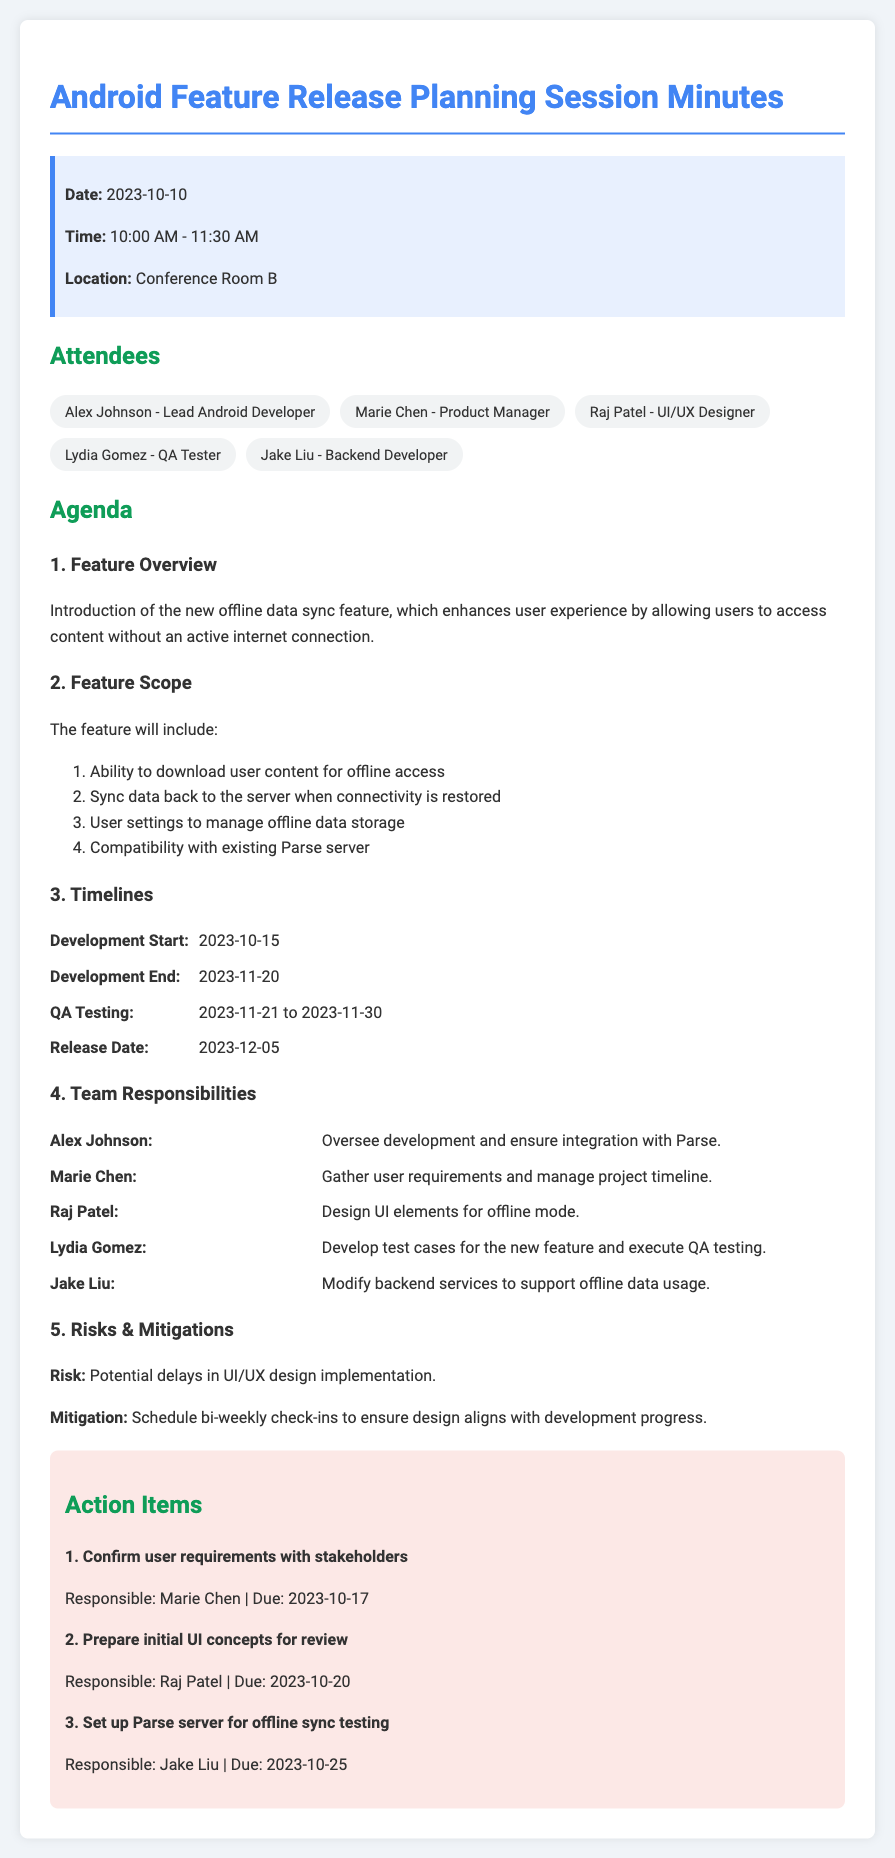What is the date of the meeting? The date of the meeting is explicitly mentioned in the document.
Answer: 2023-10-10 Who is responsible for gathering user requirements? The responsibilities section lists Marie Chen as the person responsible for this task.
Answer: Marie Chen What is the development end date? This date is specified in the timeline section of the document.
Answer: 2023-11-20 What feature is being introduced? The document provides an overview of the new feature in the agenda.
Answer: Offline data sync feature What is the release date for the new feature? The timeline section indicates the scheduled release date.
Answer: 2023-12-05 What mitigation strategy is mentioned for UI/UX design delays? The risks and mitigations section outlines this strategy.
Answer: Schedule bi-weekly check-ins How many action items are listed? The action items section counts the number of tasks mentioned.
Answer: 3 What is Raj Patel's role in the team? The responsibilities section defines Raj Patel's role related to the new feature.
Answer: Design UI elements for offline mode What is the QA testing duration? The timeline section specifies the duration for QA testing.
Answer: 2023-11-21 to 2023-11-30 